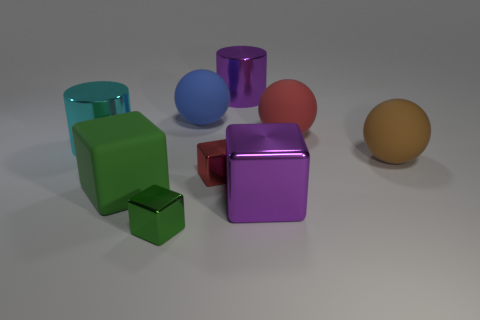Subtract 1 blocks. How many blocks are left? 3 Subtract all purple blocks. How many blocks are left? 3 Subtract all red blocks. How many blocks are left? 3 Add 1 purple metallic cylinders. How many objects exist? 10 Subtract all yellow blocks. Subtract all purple balls. How many blocks are left? 4 Subtract all cylinders. How many objects are left? 7 Add 1 blue matte objects. How many blue matte objects are left? 2 Add 4 large green objects. How many large green objects exist? 5 Subtract 0 gray balls. How many objects are left? 9 Subtract all red balls. Subtract all brown things. How many objects are left? 7 